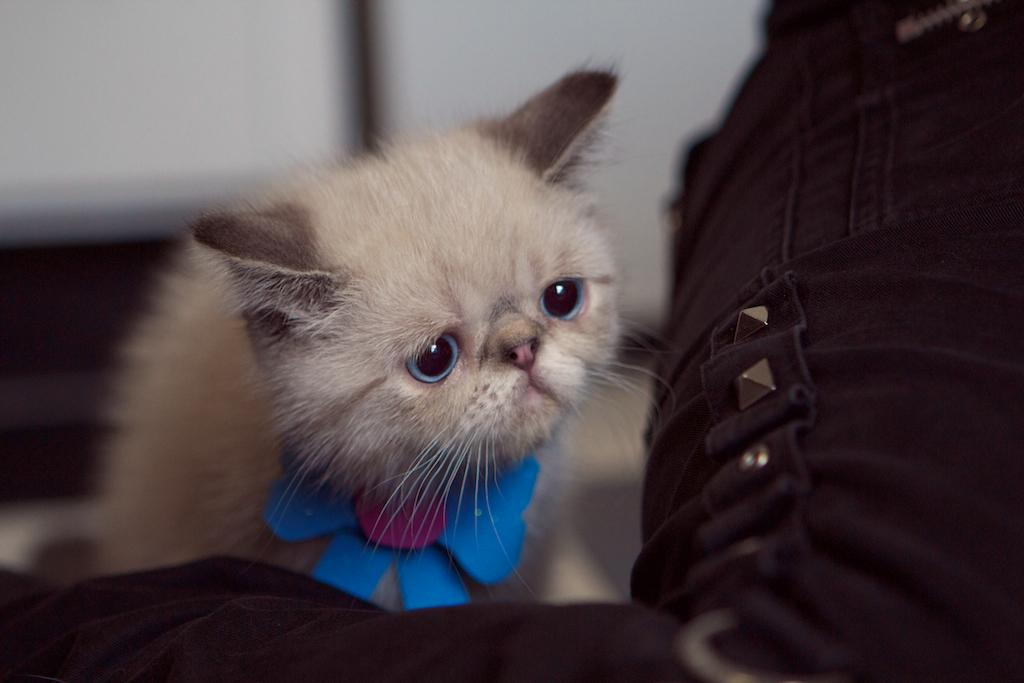What type of animal is in the image? There is a cat in the image. What object can be seen in the image besides the cat? There is a cloth in the image. How would you describe the background of the image? The background of the image is blurry and white. What type of berry is the cat holding in the image? There is no berry present in the image, and the cat is not holding anything. 